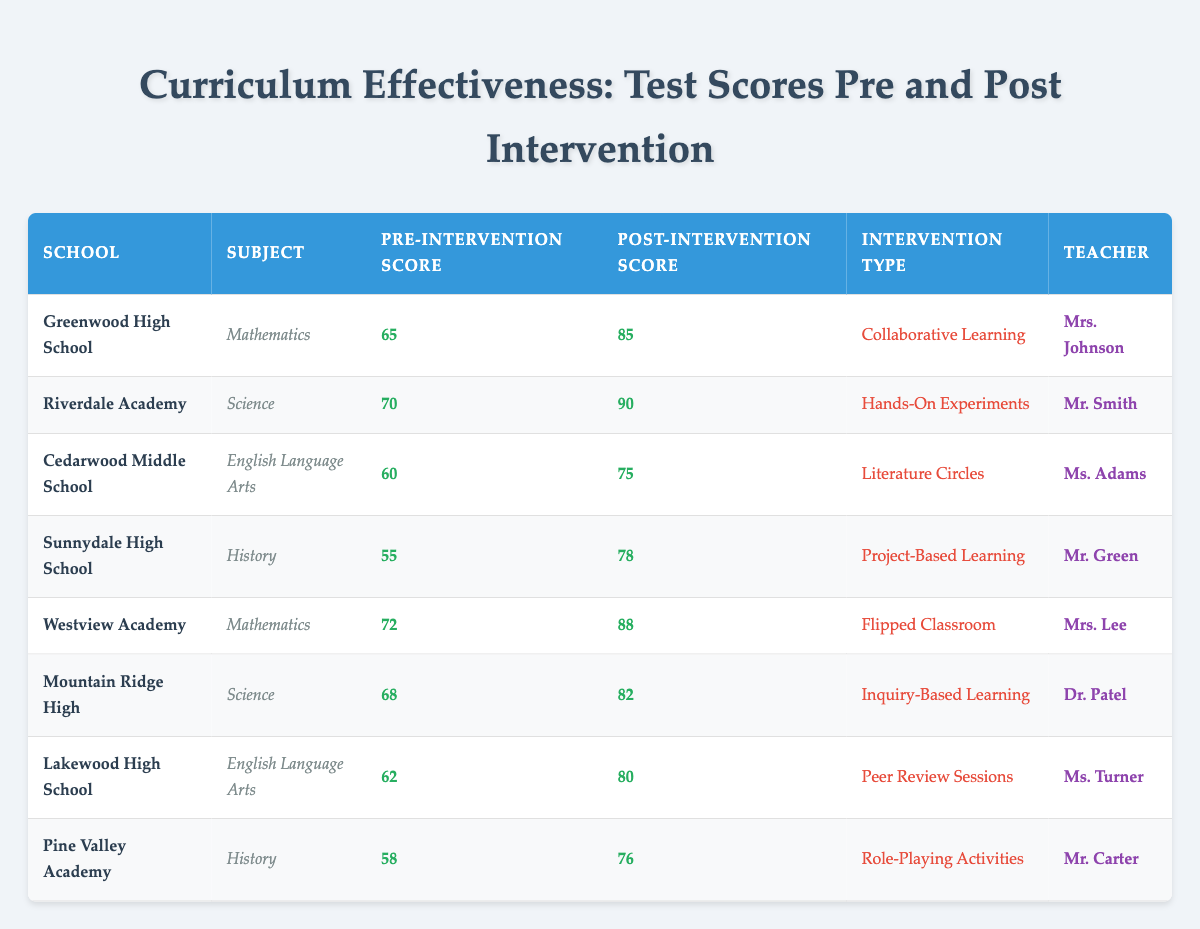What is the highest post-intervention test score in the table? To find the highest post-intervention score, I look at the scores in the "Post-Intervention Score" column. The highest value is 90 from Riverdale Academy.
Answer: 90 Which school had the lowest pre-intervention score? I examine the "Pre-Intervention Score" column and find that Sunnydale High School has the lowest score of 55.
Answer: Sunnydale High School What was the improvement in test scores for Cedarwood Middle School? The improvement is calculated by subtracting the pre-intervention score (60) from the post-intervention score (75), resulting in an increase of 15 points.
Answer: 15 Did any school have a post-intervention score less than 80? By checking the "Post-Intervention Score" column, I see that both Cedarwood Middle School (75) and Pine Valley Academy (76) had scores below 80.
Answer: Yes What is the average pre-intervention score across all schools? To find the average, I add the pre-intervention scores: 65 + 70 + 60 + 55 + 72 + 68 + 62 + 58 = 420. There are 8 schools, so the average is 420 / 8 = 52.5.
Answer: 52.5 Which intervention type resulted in the highest post-intervention score? Looking at the post-intervention scores and their corresponding intervention types, "Hands-On Experiments" at Riverdale Academy yielded the highest score of 90.
Answer: Hands-On Experiments How much did test scores improve in Westview Academy? I subtract the pre-intervention score (72) from the post-intervention score (88), leading to an improvement of 16 points.
Answer: 16 Which subject had the lowest improvement in scores post-intervention? Comparing the improvements: Mathematics (20), Science (14), English Language Arts (15), History (21). The lowest improvement is in Science by 14 points (Mountain Ridge High).
Answer: Science What was the post-intervention score for Lakewood High School? Referring to the table, Lakewood High School achieved a post-intervention score of 80.
Answer: 80 Is there a relationship between intervention types and score improvements? Upon inspecting, the results show that hands-on experiments and project-based learning had higher improvements, while some other interventions had moderate improvements, indicating a potential correlation.
Answer: Yes What percentage increase in scores did Sunnydale High School experience? The percentage increase is calculated as ((78 - 55) / 55) * 100, which results in approximately 41.82%.
Answer: 41.82% 